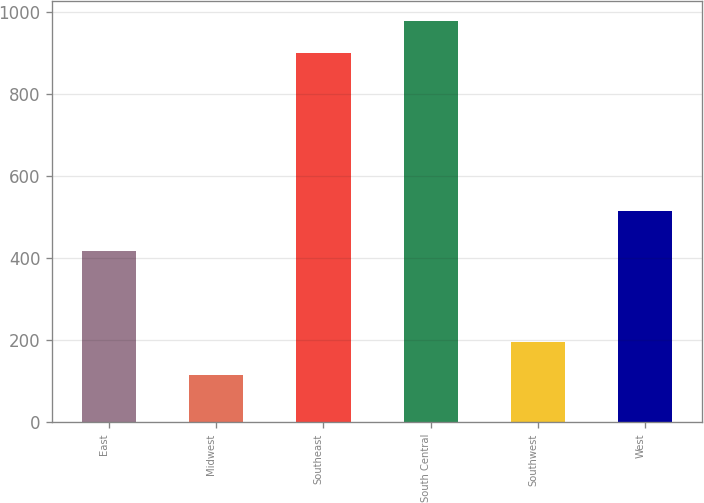<chart> <loc_0><loc_0><loc_500><loc_500><bar_chart><fcel>East<fcel>Midwest<fcel>Southeast<fcel>South Central<fcel>Southwest<fcel>West<nl><fcel>416.7<fcel>115.2<fcel>899.2<fcel>979<fcel>195<fcel>515.7<nl></chart> 